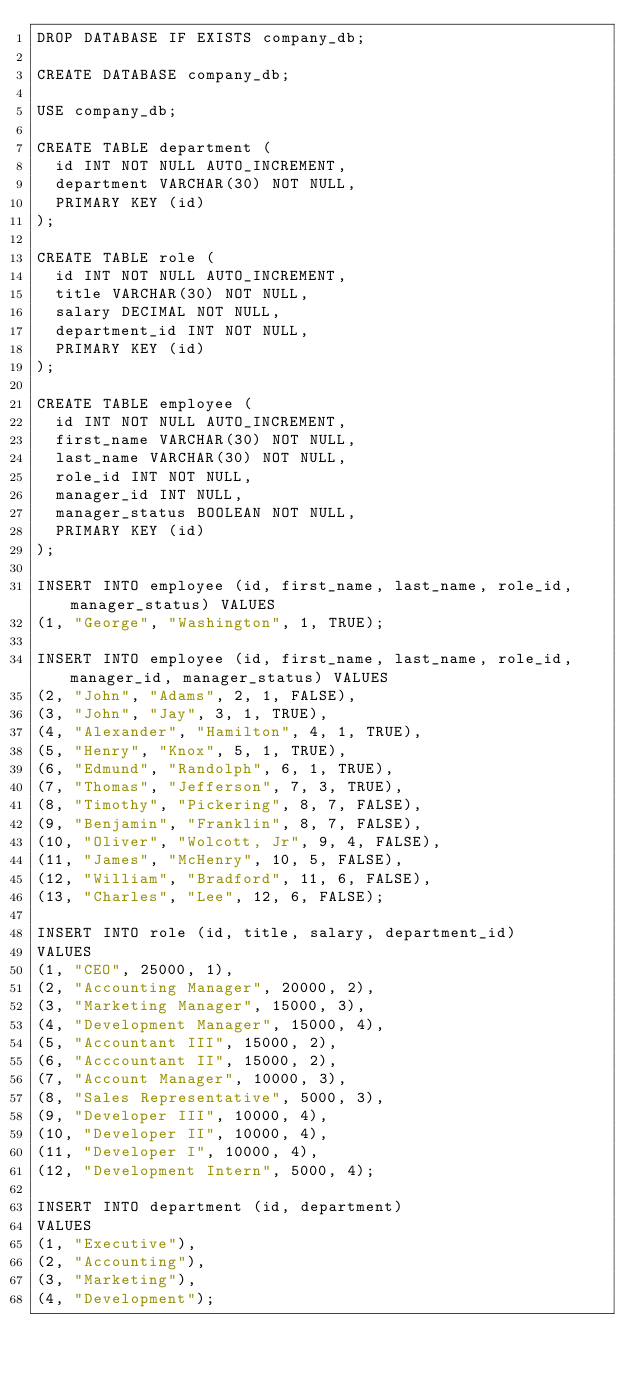Convert code to text. <code><loc_0><loc_0><loc_500><loc_500><_SQL_>DROP DATABASE IF EXISTS company_db;

CREATE DATABASE company_db;

USE company_db;

CREATE TABLE department (
  id INT NOT NULL AUTO_INCREMENT,
  department VARCHAR(30) NOT NULL,
  PRIMARY KEY (id)
);

CREATE TABLE role (
  id INT NOT NULL AUTO_INCREMENT,
  title VARCHAR(30) NOT NULL,
  salary DECIMAL NOT NULL,
  department_id INT NOT NULL,
  PRIMARY KEY (id)
);

CREATE TABLE employee (
  id INT NOT NULL AUTO_INCREMENT,
  first_name VARCHAR(30) NOT NULL,
  last_name VARCHAR(30) NOT NULL,
  role_id INT NOT NULL,
  manager_id INT NULL,
  manager_status BOOLEAN NOT NULL,
  PRIMARY KEY (id)
);

INSERT INTO employee (id, first_name, last_name, role_id, manager_status) VALUES 
(1, "George", "Washington", 1, TRUE);

INSERT INTO employee (id, first_name, last_name, role_id, manager_id, manager_status) VALUES 
(2, "John", "Adams", 2, 1, FALSE), 
(3, "John", "Jay", 3, 1, TRUE), 
(4, "Alexander", "Hamilton", 4, 1, TRUE), 
(5, "Henry", "Knox", 5, 1, TRUE), 
(6, "Edmund", "Randolph", 6, 1, TRUE), 
(7, "Thomas", "Jefferson", 7, 3, TRUE),
(8, "Timothy", "Pickering", 8, 7, FALSE), 
(9, "Benjamin", "Franklin", 8, 7, FALSE), 
(10, "Oliver", "Wolcott, Jr", 9, 4, FALSE), 
(11, "James", "McHenry", 10, 5, FALSE), 
(12, "William", "Bradford", 11, 6, FALSE), 
(13, "Charles", "Lee", 12, 6, FALSE);

INSERT INTO role (id, title, salary, department_id)
VALUES 
(1, "CEO", 25000, 1), 
(2, "Accounting Manager", 20000, 2), 
(3, "Marketing Manager", 15000, 3), 
(4, "Development Manager", 15000, 4),
(5, "Accountant III", 15000, 2), 
(6, "Acccountant II", 15000, 2), 
(7, "Account Manager", 10000, 3), 
(8, "Sales Representative", 5000, 3), 
(9, "Developer III", 10000, 4), 
(10, "Developer II", 10000, 4), 
(11, "Developer I", 10000, 4), 
(12, "Development Intern", 5000, 4);

INSERT INTO department (id, department)
VALUES 
(1, "Executive"), 
(2, "Accounting"), 
(3, "Marketing"), 
(4, "Development");
</code> 